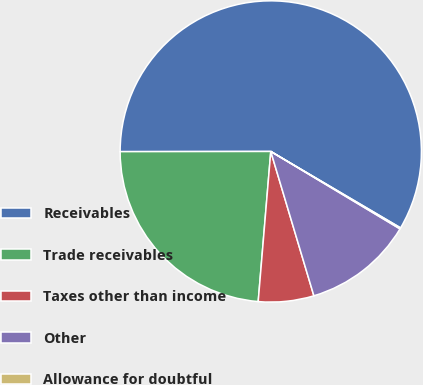Convert chart to OTSL. <chart><loc_0><loc_0><loc_500><loc_500><pie_chart><fcel>Receivables<fcel>Trade receivables<fcel>Taxes other than income<fcel>Other<fcel>Allowance for doubtful<nl><fcel>58.49%<fcel>23.65%<fcel>5.95%<fcel>11.79%<fcel>0.12%<nl></chart> 